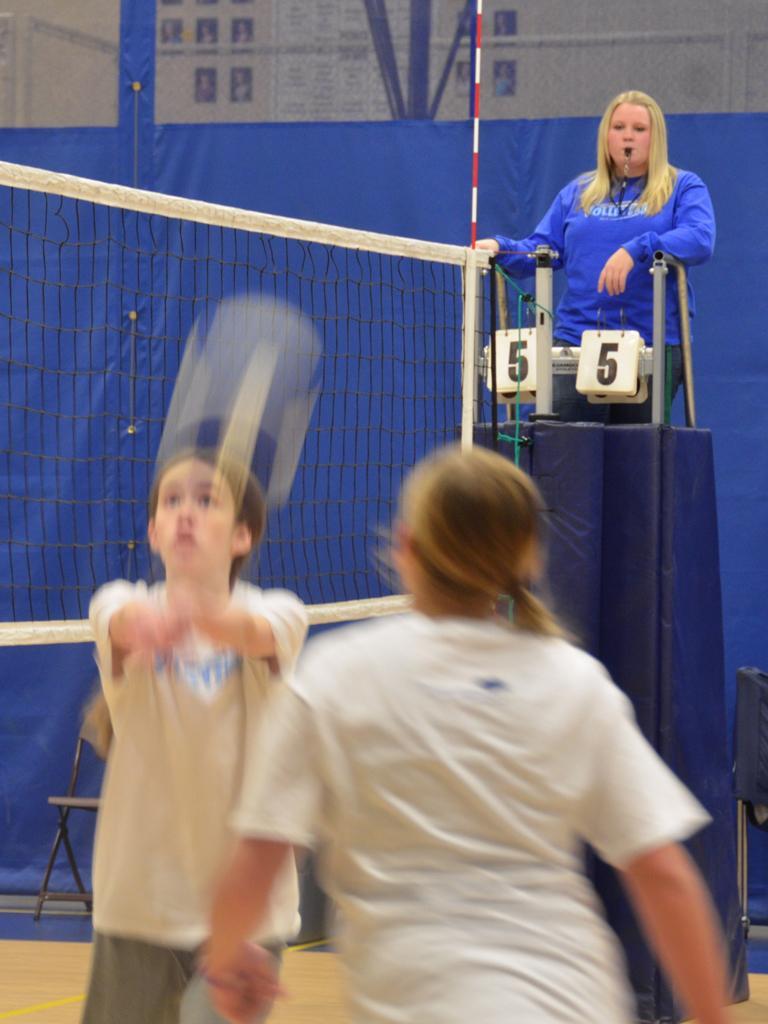Could you give a brief overview of what you see in this image? At the bottom of the image two persons are standing and holding tennis rackets. Behind them there is net and chair. At the top of the image a woman is standing and watching. Behind her there is a wall and curtain. 